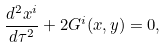Convert formula to latex. <formula><loc_0><loc_0><loc_500><loc_500>\frac { d ^ { 2 } x ^ { i } } { d \tau ^ { 2 } } + 2 G ^ { i } ( x , y ) = 0 ,</formula> 